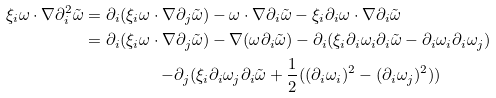<formula> <loc_0><loc_0><loc_500><loc_500>\xi _ { i } \omega \cdot \nabla \partial _ { i } ^ { 2 } \tilde { \omega } = \partial _ { i } ( \xi _ { i } \omega \cdot \nabla \partial _ { j } \tilde { \omega } ) & - \omega \cdot \nabla \partial _ { i } \tilde { \omega } - \xi _ { i } \partial _ { i } \omega \cdot \nabla \partial _ { i } \tilde { \omega } \\ = \partial _ { i } ( \xi _ { i } \omega \cdot \nabla \partial _ { j } \tilde { \omega } ) & - \nabla ( \omega \partial _ { i } \tilde { \omega } ) - \partial _ { i } ( \xi _ { i } \partial _ { i } \omega _ { i } \partial _ { i } \tilde { \omega } - \partial _ { i } \omega _ { i } \partial _ { i } \omega _ { j } ) \\ - \partial _ { j } ( \xi _ { i } & \partial _ { i } \omega _ { j } \partial _ { i } \tilde { \omega } + \frac { 1 } { 2 } ( ( \partial _ { i } \omega _ { i } ) ^ { 2 } - ( \partial _ { i } \omega _ { j } ) ^ { 2 } ) )</formula> 